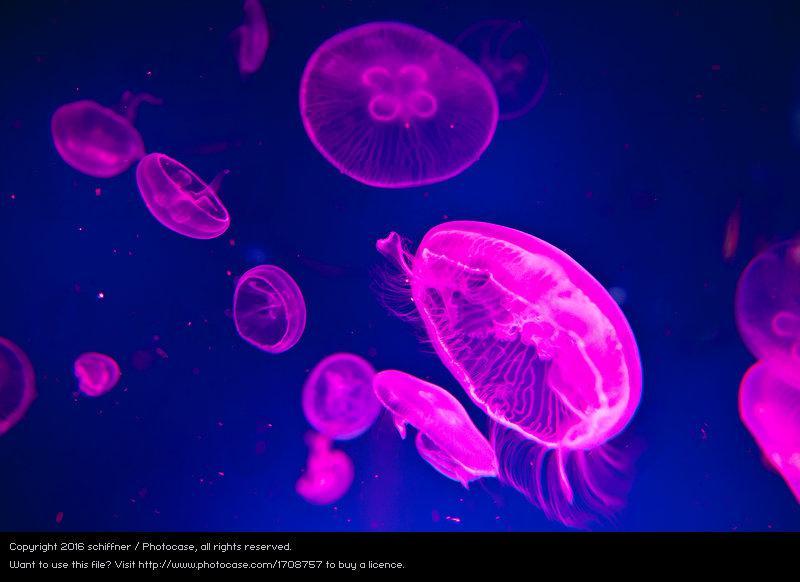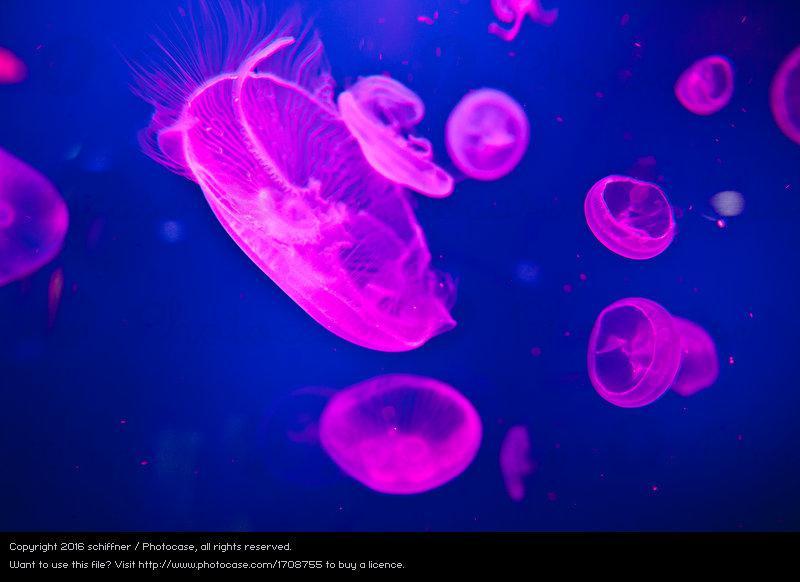The first image is the image on the left, the second image is the image on the right. For the images shown, is this caption "There is a single upright jellyfish in one of the images." true? Answer yes or no. No. The first image is the image on the left, the second image is the image on the right. Evaluate the accuracy of this statement regarding the images: "Exactly one image shows multiple hot pink jellyfish on a blue backdrop.". Is it true? Answer yes or no. No. 